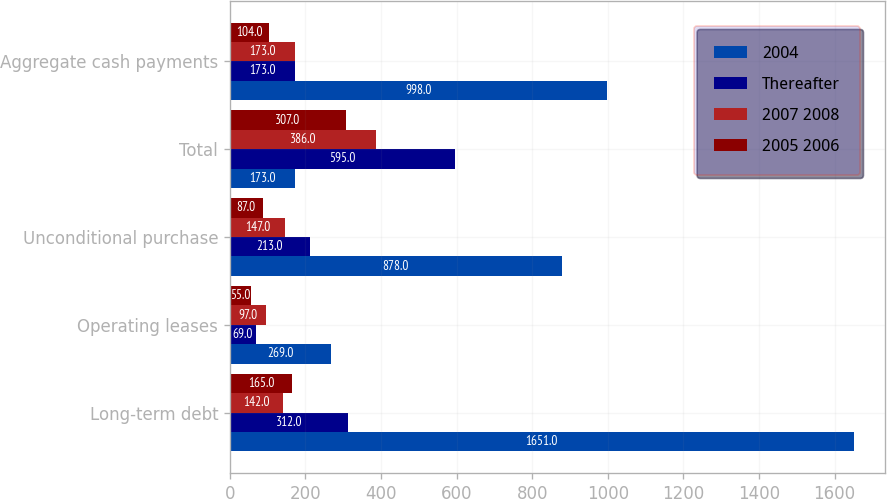Convert chart. <chart><loc_0><loc_0><loc_500><loc_500><stacked_bar_chart><ecel><fcel>Long-term debt<fcel>Operating leases<fcel>Unconditional purchase<fcel>Total<fcel>Aggregate cash payments<nl><fcel>2004<fcel>1651<fcel>269<fcel>878<fcel>173<fcel>998<nl><fcel>Thereafter<fcel>312<fcel>69<fcel>213<fcel>595<fcel>173<nl><fcel>2007 2008<fcel>142<fcel>97<fcel>147<fcel>386<fcel>173<nl><fcel>2005 2006<fcel>165<fcel>55<fcel>87<fcel>307<fcel>104<nl></chart> 